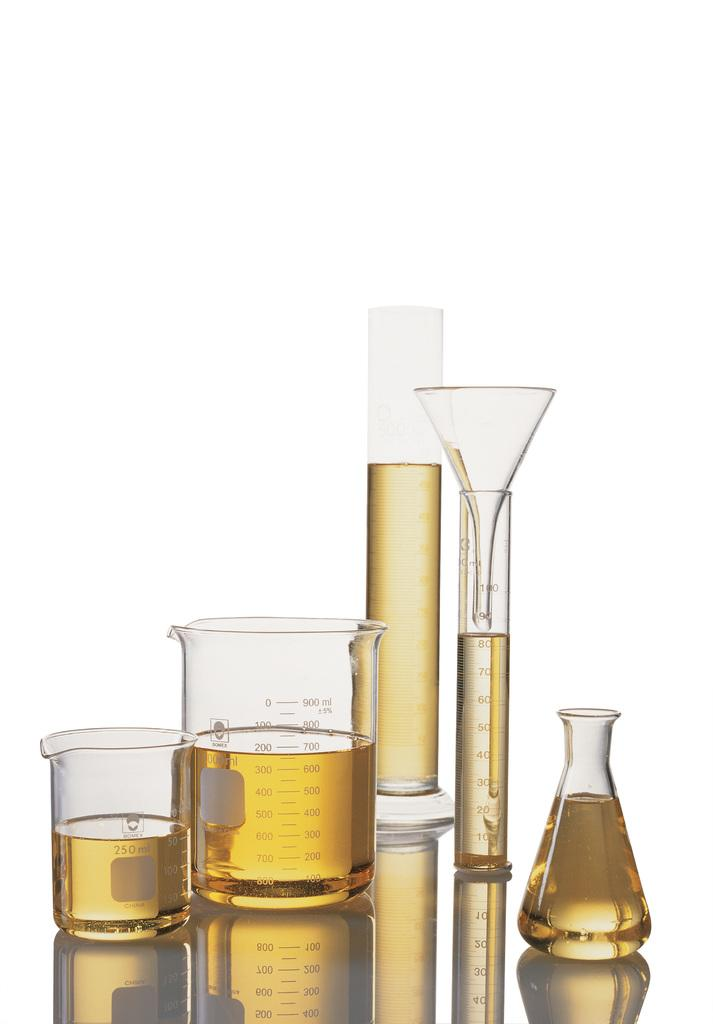<image>
Offer a succinct explanation of the picture presented. Fiver measuing cups and sticks from Bomex that measure Ml. 